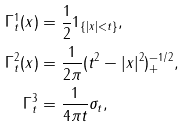Convert formula to latex. <formula><loc_0><loc_0><loc_500><loc_500>\Gamma _ { t } ^ { 1 } ( x ) & = \frac { 1 } { 2 } { 1 } _ { \{ | x | < t \} } , \\ \Gamma _ { t } ^ { 2 } ( x ) & = \frac { 1 } { 2 \pi } ( t ^ { 2 } - | x | ^ { 2 } ) _ { + } ^ { - 1 / 2 } , \\ \Gamma _ { t } ^ { 3 } & = \frac { 1 } { 4 \pi t } \sigma _ { t } ,</formula> 